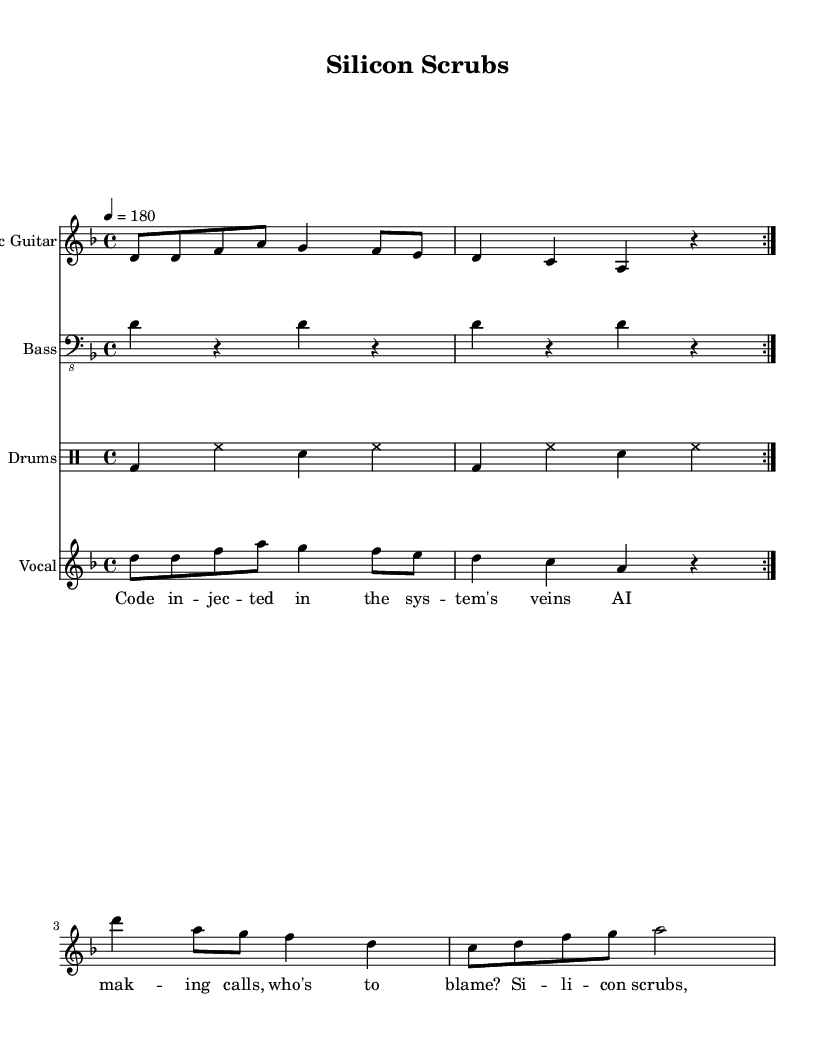What is the key signature of this music? The key signature is indicated at the start of the sheet music, which shows one flat (B♭) in the key of D minor.
Answer: D minor What is the time signature of this piece? The time signature, found at the beginning of the sheet music, shows that there are four beats in each measure.
Answer: 4/4 What is the tempo marking for this song? The tempo marking is indicated by the number of beats per minute given at the start, specifying the speed at which the music should be played.
Answer: 180 How many times is the verse repeated? The repetition structure is indicated in the score, with a repeat sign showing that the verse section must be played twice.
Answer: 2 What instrument plays the main melody? The staff labeled "Electric Guitar" shows that this instrument carries the primary melody throughout the song.
Answer: Electric Guitar What lyrical theme does this song focus on? The lyrics discuss themes related to technology and ethics in healthcare, reflecting concerns about AI control.
Answer: AI ethics What kind of musical style does this song exemplify? The genre elements are reflected in the song's instrumental setup and lyrical content, matching the aggressive and politically charged characteristics of a specific music style.
Answer: Anarcho-punk 